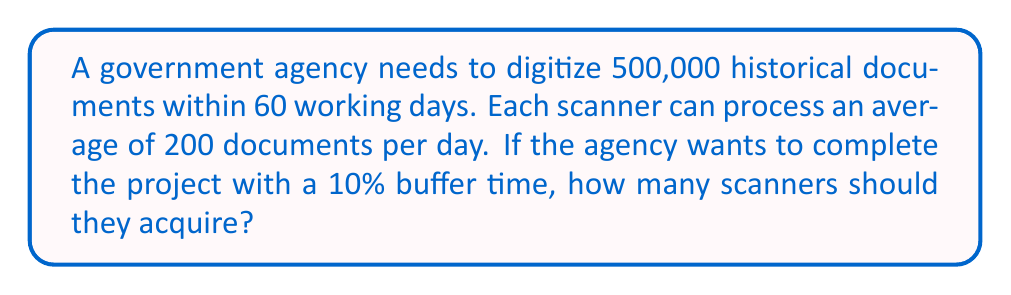What is the answer to this math problem? Let's approach this problem step-by-step:

1. Calculate the total number of documents to be scanned:
   $$ \text{Total documents} = 500,000 $$

2. Determine the available working days with a 10% buffer:
   $$ \text{Available days} = 60 \times 0.9 = 54 \text{ days} $$

3. Calculate the total number of documents that need to be scanned per day:
   $$ \text{Documents per day} = \frac{\text{Total documents}}{\text{Available days}} = \frac{500,000}{54} \approx 9,259.26 $$

4. Determine the number of scanners needed:
   $$ \text{Number of scanners} = \frac{\text{Documents per day}}{\text{Documents per scanner per day}} = \frac{9,259.26}{200} \approx 46.30 $$

5. Round up to the nearest whole number, as we can't have a fractional scanner:
   $$ \text{Optimal number of scanners} = \lceil 46.30 \rceil = 47 $$

Therefore, the agency should acquire 47 scanners to complete the digitization project within the given timeframe, including the 10% buffer.
Answer: 47 scanners 